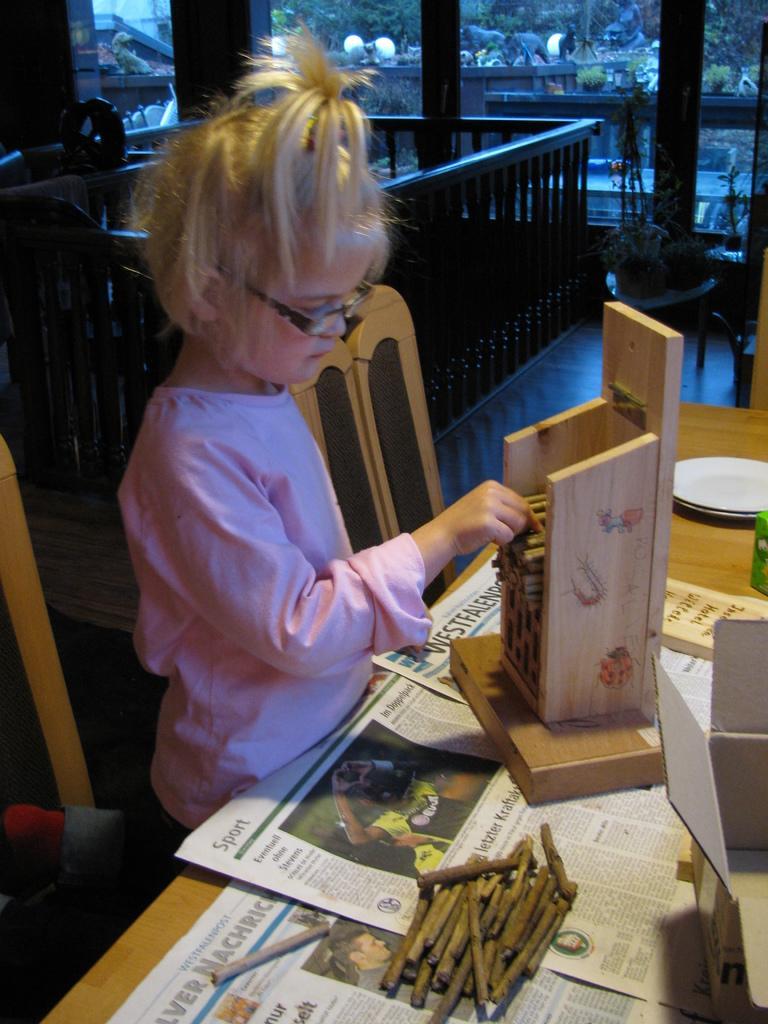Please provide a concise description of this image. In this image, there is kid wearing clothes and standing in front of the table. This table contains boxes, plates and sticks. There is a chair in the middle of the image. 